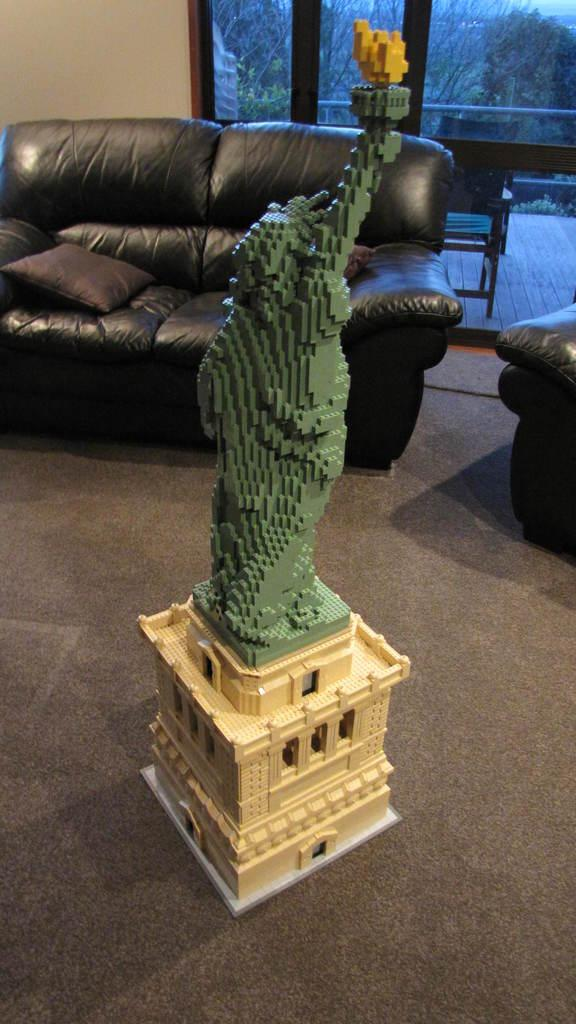What is on the carpet in the image? There is a building block statue on the carpet. What furniture can be seen in the background? There is a couch, a pillow, a window, and a chair in the background. What is visible through the window? There is a tree visible through the window. What type of beef is being cooked in the image? There is no beef or cooking activity present in the image. Can you tell me what kind of toothpaste is on the pillow in the image? There is no toothpaste visible in the image; only a pillow is mentioned in the background. 